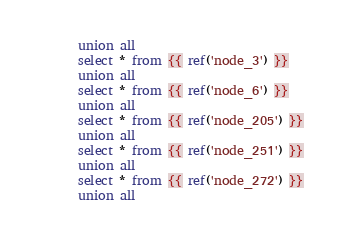<code> <loc_0><loc_0><loc_500><loc_500><_SQL_>union all
select * from {{ ref('node_3') }}
union all
select * from {{ ref('node_6') }}
union all
select * from {{ ref('node_205') }}
union all
select * from {{ ref('node_251') }}
union all
select * from {{ ref('node_272') }}
union all</code> 